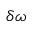Convert formula to latex. <formula><loc_0><loc_0><loc_500><loc_500>\delta \omega</formula> 